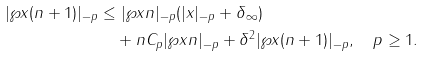<formula> <loc_0><loc_0><loc_500><loc_500>| \wp x { ( n + 1 ) } | _ { - p } & \leq | \wp x { n } | _ { - p } ( | x | _ { - p } + \| \delta \| _ { \infty } ) \\ & \quad + n C _ { p } | \wp x { n } | _ { - p } + \| \delta \| ^ { 2 } | \wp x { ( n + 1 ) } | _ { - p } , \quad p \geq 1 .</formula> 